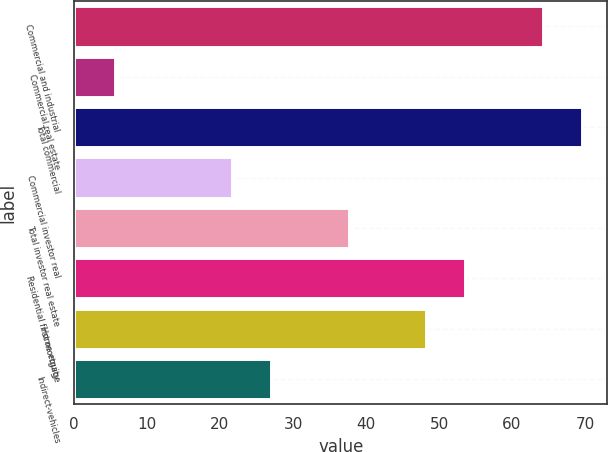<chart> <loc_0><loc_0><loc_500><loc_500><bar_chart><fcel>Commercial and industrial<fcel>Commercial real estate<fcel>Total commercial<fcel>Commercial investor real<fcel>Total investor real estate<fcel>Residential first mortgage<fcel>Home equity<fcel>Indirect-vehicles<nl><fcel>64.26<fcel>5.63<fcel>69.59<fcel>21.62<fcel>37.61<fcel>53.6<fcel>48.27<fcel>26.95<nl></chart> 